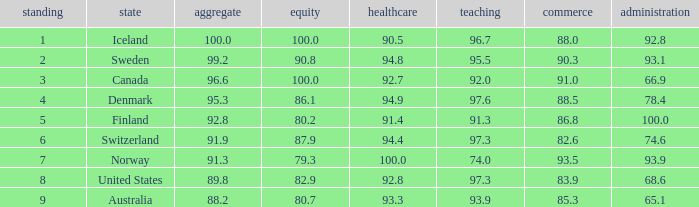What's the economics score with justice being 90.8 90.3. 